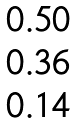Convert formula to latex. <formula><loc_0><loc_0><loc_500><loc_500>\begin{matrix} 0 . 5 0 \\ 0 . 3 6 \\ 0 . 1 4 \\ \end{matrix}</formula> 